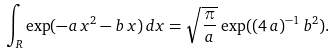<formula> <loc_0><loc_0><loc_500><loc_500>\int _ { R } \exp ( - a \, x ^ { 2 } - b \, x ) \, d x = \sqrt { \frac { \pi } { a } } \, \exp ( ( 4 \, a ) ^ { - 1 } \, b ^ { 2 } ) .</formula> 